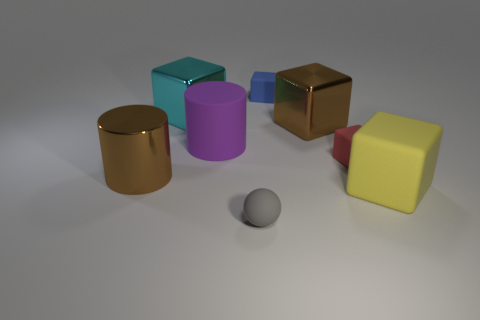There is a brown metallic object on the right side of the matte object in front of the large yellow block; how many small balls are behind it?
Make the answer very short. 0. There is a big brown object that is in front of the large purple rubber cylinder; is it the same shape as the blue thing?
Offer a very short reply. No. What number of things are either yellow matte things or big objects that are to the left of the red matte cube?
Offer a very short reply. 5. Are there more rubber balls that are to the right of the yellow rubber object than rubber cylinders?
Keep it short and to the point. No. Is the number of tiny blue rubber things that are behind the large rubber cylinder the same as the number of large shiny blocks that are to the right of the gray rubber sphere?
Make the answer very short. Yes. There is a large cube left of the rubber cylinder; are there any rubber things that are behind it?
Your response must be concise. Yes. There is a big cyan thing; what shape is it?
Offer a terse response. Cube. What size is the thing that is the same color as the big metallic cylinder?
Your response must be concise. Large. What is the size of the brown metal object left of the metal thing right of the matte ball?
Provide a succinct answer. Large. There is a matte object that is right of the small red block; what size is it?
Ensure brevity in your answer.  Large. 